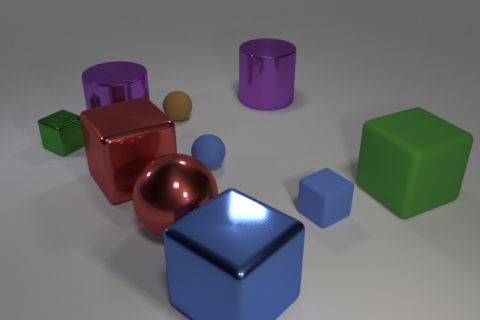Are there any metal cylinders right of the tiny green thing?
Offer a terse response. Yes. What size is the other thing that is the same color as the tiny metallic thing?
Keep it short and to the point. Large. Is there a tiny cube made of the same material as the tiny brown sphere?
Make the answer very short. Yes. What is the color of the tiny rubber cube?
Offer a terse response. Blue. Does the blue matte object in front of the red block have the same shape as the small brown object?
Give a very brief answer. No. What shape is the small object to the left of the purple cylinder that is left of the red metallic thing behind the green matte cube?
Make the answer very short. Cube. What is the big cylinder in front of the brown matte thing made of?
Provide a short and direct response. Metal. The rubber cube that is the same size as the shiny sphere is what color?
Keep it short and to the point. Green. What number of other things are there of the same shape as the brown rubber thing?
Your answer should be very brief. 2. Is the blue ball the same size as the red shiny cube?
Make the answer very short. No. 